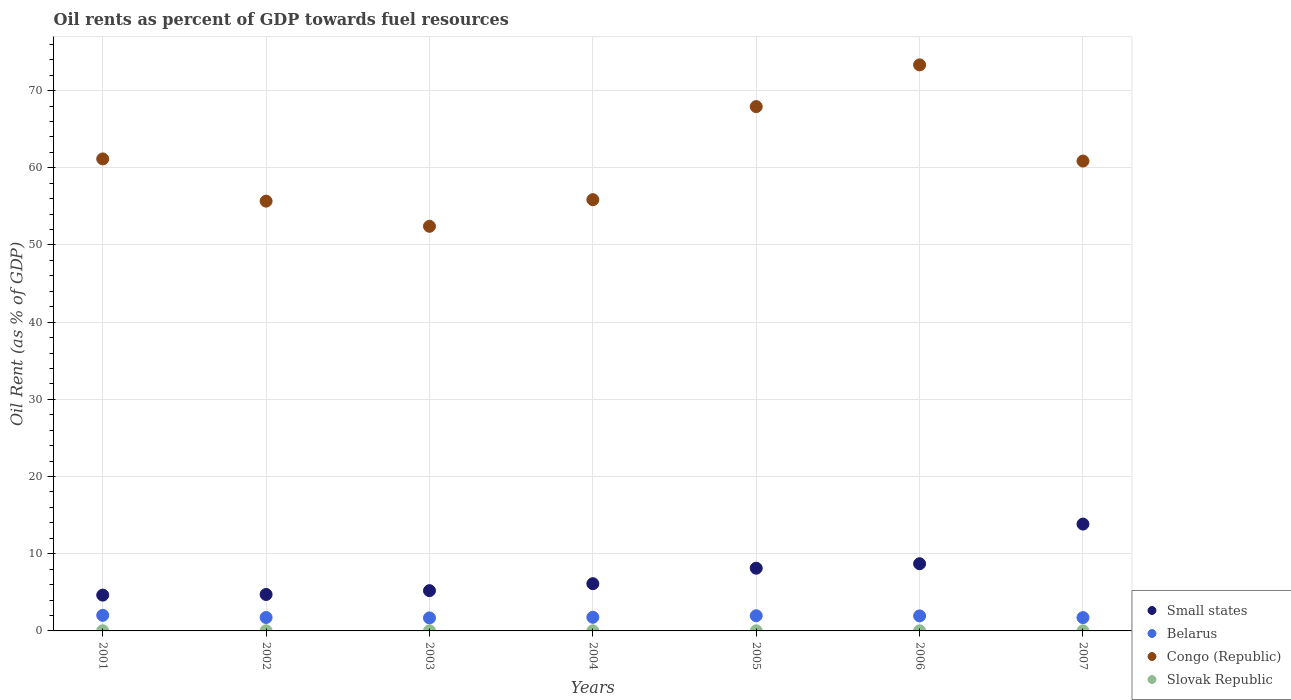How many different coloured dotlines are there?
Offer a very short reply. 4. Is the number of dotlines equal to the number of legend labels?
Make the answer very short. Yes. What is the oil rent in Congo (Republic) in 2001?
Make the answer very short. 61.15. Across all years, what is the maximum oil rent in Congo (Republic)?
Give a very brief answer. 73.33. Across all years, what is the minimum oil rent in Belarus?
Ensure brevity in your answer.  1.69. In which year was the oil rent in Belarus maximum?
Make the answer very short. 2001. In which year was the oil rent in Belarus minimum?
Offer a very short reply. 2003. What is the total oil rent in Congo (Republic) in the graph?
Make the answer very short. 427.25. What is the difference between the oil rent in Slovak Republic in 2005 and that in 2006?
Your response must be concise. 0. What is the difference between the oil rent in Small states in 2003 and the oil rent in Belarus in 2005?
Your answer should be compact. 3.25. What is the average oil rent in Belarus per year?
Provide a succinct answer. 1.84. In the year 2001, what is the difference between the oil rent in Congo (Republic) and oil rent in Belarus?
Ensure brevity in your answer.  59.13. What is the ratio of the oil rent in Congo (Republic) in 2003 to that in 2007?
Keep it short and to the point. 0.86. What is the difference between the highest and the second highest oil rent in Slovak Republic?
Give a very brief answer. 0. What is the difference between the highest and the lowest oil rent in Small states?
Your response must be concise. 9.2. Is the oil rent in Slovak Republic strictly greater than the oil rent in Belarus over the years?
Offer a very short reply. No. Is the oil rent in Congo (Republic) strictly less than the oil rent in Belarus over the years?
Offer a terse response. No. Does the graph contain any zero values?
Provide a short and direct response. No. Does the graph contain grids?
Offer a very short reply. Yes. Where does the legend appear in the graph?
Provide a succinct answer. Bottom right. What is the title of the graph?
Provide a short and direct response. Oil rents as percent of GDP towards fuel resources. Does "Channel Islands" appear as one of the legend labels in the graph?
Give a very brief answer. No. What is the label or title of the Y-axis?
Your answer should be very brief. Oil Rent (as % of GDP). What is the Oil Rent (as % of GDP) of Small states in 2001?
Your response must be concise. 4.64. What is the Oil Rent (as % of GDP) of Belarus in 2001?
Offer a very short reply. 2.02. What is the Oil Rent (as % of GDP) in Congo (Republic) in 2001?
Provide a short and direct response. 61.15. What is the Oil Rent (as % of GDP) in Slovak Republic in 2001?
Offer a terse response. 0.02. What is the Oil Rent (as % of GDP) in Small states in 2002?
Offer a terse response. 4.72. What is the Oil Rent (as % of GDP) of Belarus in 2002?
Give a very brief answer. 1.74. What is the Oil Rent (as % of GDP) of Congo (Republic) in 2002?
Your answer should be compact. 55.68. What is the Oil Rent (as % of GDP) in Slovak Republic in 2002?
Keep it short and to the point. 0.02. What is the Oil Rent (as % of GDP) in Small states in 2003?
Give a very brief answer. 5.22. What is the Oil Rent (as % of GDP) of Belarus in 2003?
Offer a terse response. 1.69. What is the Oil Rent (as % of GDP) in Congo (Republic) in 2003?
Give a very brief answer. 52.42. What is the Oil Rent (as % of GDP) in Slovak Republic in 2003?
Your answer should be compact. 0.01. What is the Oil Rent (as % of GDP) in Small states in 2004?
Provide a short and direct response. 6.12. What is the Oil Rent (as % of GDP) of Belarus in 2004?
Offer a terse response. 1.77. What is the Oil Rent (as % of GDP) in Congo (Republic) in 2004?
Offer a very short reply. 55.87. What is the Oil Rent (as % of GDP) of Slovak Republic in 2004?
Your answer should be compact. 0.02. What is the Oil Rent (as % of GDP) in Small states in 2005?
Give a very brief answer. 8.13. What is the Oil Rent (as % of GDP) of Belarus in 2005?
Ensure brevity in your answer.  1.97. What is the Oil Rent (as % of GDP) of Congo (Republic) in 2005?
Give a very brief answer. 67.93. What is the Oil Rent (as % of GDP) in Slovak Republic in 2005?
Offer a very short reply. 0.02. What is the Oil Rent (as % of GDP) in Small states in 2006?
Provide a succinct answer. 8.7. What is the Oil Rent (as % of GDP) of Belarus in 2006?
Your answer should be compact. 1.94. What is the Oil Rent (as % of GDP) in Congo (Republic) in 2006?
Offer a very short reply. 73.33. What is the Oil Rent (as % of GDP) of Slovak Republic in 2006?
Keep it short and to the point. 0.02. What is the Oil Rent (as % of GDP) in Small states in 2007?
Your answer should be compact. 13.84. What is the Oil Rent (as % of GDP) in Belarus in 2007?
Make the answer very short. 1.73. What is the Oil Rent (as % of GDP) in Congo (Republic) in 2007?
Make the answer very short. 60.87. What is the Oil Rent (as % of GDP) of Slovak Republic in 2007?
Your response must be concise. 0.01. Across all years, what is the maximum Oil Rent (as % of GDP) of Small states?
Keep it short and to the point. 13.84. Across all years, what is the maximum Oil Rent (as % of GDP) of Belarus?
Give a very brief answer. 2.02. Across all years, what is the maximum Oil Rent (as % of GDP) of Congo (Republic)?
Your answer should be compact. 73.33. Across all years, what is the maximum Oil Rent (as % of GDP) of Slovak Republic?
Offer a very short reply. 0.02. Across all years, what is the minimum Oil Rent (as % of GDP) in Small states?
Your answer should be compact. 4.64. Across all years, what is the minimum Oil Rent (as % of GDP) in Belarus?
Give a very brief answer. 1.69. Across all years, what is the minimum Oil Rent (as % of GDP) of Congo (Republic)?
Provide a short and direct response. 52.42. Across all years, what is the minimum Oil Rent (as % of GDP) in Slovak Republic?
Ensure brevity in your answer.  0.01. What is the total Oil Rent (as % of GDP) of Small states in the graph?
Provide a succinct answer. 51.37. What is the total Oil Rent (as % of GDP) of Belarus in the graph?
Provide a short and direct response. 12.85. What is the total Oil Rent (as % of GDP) in Congo (Republic) in the graph?
Ensure brevity in your answer.  427.25. What is the total Oil Rent (as % of GDP) in Slovak Republic in the graph?
Give a very brief answer. 0.11. What is the difference between the Oil Rent (as % of GDP) of Small states in 2001 and that in 2002?
Make the answer very short. -0.08. What is the difference between the Oil Rent (as % of GDP) in Belarus in 2001 and that in 2002?
Offer a very short reply. 0.28. What is the difference between the Oil Rent (as % of GDP) of Congo (Republic) in 2001 and that in 2002?
Your answer should be compact. 5.47. What is the difference between the Oil Rent (as % of GDP) in Slovak Republic in 2001 and that in 2002?
Make the answer very short. 0. What is the difference between the Oil Rent (as % of GDP) in Small states in 2001 and that in 2003?
Provide a short and direct response. -0.58. What is the difference between the Oil Rent (as % of GDP) in Belarus in 2001 and that in 2003?
Your answer should be compact. 0.34. What is the difference between the Oil Rent (as % of GDP) of Congo (Republic) in 2001 and that in 2003?
Offer a terse response. 8.73. What is the difference between the Oil Rent (as % of GDP) of Slovak Republic in 2001 and that in 2003?
Your response must be concise. 0.01. What is the difference between the Oil Rent (as % of GDP) of Small states in 2001 and that in 2004?
Offer a very short reply. -1.48. What is the difference between the Oil Rent (as % of GDP) in Belarus in 2001 and that in 2004?
Provide a succinct answer. 0.26. What is the difference between the Oil Rent (as % of GDP) in Congo (Republic) in 2001 and that in 2004?
Offer a very short reply. 5.28. What is the difference between the Oil Rent (as % of GDP) of Slovak Republic in 2001 and that in 2004?
Your answer should be compact. 0.01. What is the difference between the Oil Rent (as % of GDP) of Small states in 2001 and that in 2005?
Provide a succinct answer. -3.49. What is the difference between the Oil Rent (as % of GDP) in Belarus in 2001 and that in 2005?
Keep it short and to the point. 0.05. What is the difference between the Oil Rent (as % of GDP) of Congo (Republic) in 2001 and that in 2005?
Ensure brevity in your answer.  -6.78. What is the difference between the Oil Rent (as % of GDP) of Slovak Republic in 2001 and that in 2005?
Your answer should be very brief. 0. What is the difference between the Oil Rent (as % of GDP) of Small states in 2001 and that in 2006?
Make the answer very short. -4.07. What is the difference between the Oil Rent (as % of GDP) of Belarus in 2001 and that in 2006?
Ensure brevity in your answer.  0.08. What is the difference between the Oil Rent (as % of GDP) of Congo (Republic) in 2001 and that in 2006?
Provide a succinct answer. -12.18. What is the difference between the Oil Rent (as % of GDP) in Slovak Republic in 2001 and that in 2006?
Provide a succinct answer. 0. What is the difference between the Oil Rent (as % of GDP) of Small states in 2001 and that in 2007?
Keep it short and to the point. -9.2. What is the difference between the Oil Rent (as % of GDP) of Belarus in 2001 and that in 2007?
Offer a terse response. 0.3. What is the difference between the Oil Rent (as % of GDP) of Congo (Republic) in 2001 and that in 2007?
Offer a terse response. 0.28. What is the difference between the Oil Rent (as % of GDP) of Slovak Republic in 2001 and that in 2007?
Offer a very short reply. 0.01. What is the difference between the Oil Rent (as % of GDP) of Small states in 2002 and that in 2003?
Your response must be concise. -0.5. What is the difference between the Oil Rent (as % of GDP) of Belarus in 2002 and that in 2003?
Keep it short and to the point. 0.05. What is the difference between the Oil Rent (as % of GDP) in Congo (Republic) in 2002 and that in 2003?
Provide a short and direct response. 3.26. What is the difference between the Oil Rent (as % of GDP) in Slovak Republic in 2002 and that in 2003?
Ensure brevity in your answer.  0. What is the difference between the Oil Rent (as % of GDP) of Small states in 2002 and that in 2004?
Your response must be concise. -1.4. What is the difference between the Oil Rent (as % of GDP) of Belarus in 2002 and that in 2004?
Provide a short and direct response. -0.03. What is the difference between the Oil Rent (as % of GDP) in Congo (Republic) in 2002 and that in 2004?
Offer a very short reply. -0.19. What is the difference between the Oil Rent (as % of GDP) of Slovak Republic in 2002 and that in 2004?
Keep it short and to the point. 0. What is the difference between the Oil Rent (as % of GDP) of Small states in 2002 and that in 2005?
Provide a short and direct response. -3.4. What is the difference between the Oil Rent (as % of GDP) in Belarus in 2002 and that in 2005?
Give a very brief answer. -0.23. What is the difference between the Oil Rent (as % of GDP) of Congo (Republic) in 2002 and that in 2005?
Your answer should be very brief. -12.25. What is the difference between the Oil Rent (as % of GDP) of Slovak Republic in 2002 and that in 2005?
Give a very brief answer. 0. What is the difference between the Oil Rent (as % of GDP) in Small states in 2002 and that in 2006?
Provide a succinct answer. -3.98. What is the difference between the Oil Rent (as % of GDP) of Belarus in 2002 and that in 2006?
Provide a succinct answer. -0.21. What is the difference between the Oil Rent (as % of GDP) in Congo (Republic) in 2002 and that in 2006?
Your answer should be very brief. -17.65. What is the difference between the Oil Rent (as % of GDP) in Slovak Republic in 2002 and that in 2006?
Offer a terse response. 0. What is the difference between the Oil Rent (as % of GDP) of Small states in 2002 and that in 2007?
Give a very brief answer. -9.12. What is the difference between the Oil Rent (as % of GDP) of Belarus in 2002 and that in 2007?
Give a very brief answer. 0.01. What is the difference between the Oil Rent (as % of GDP) in Congo (Republic) in 2002 and that in 2007?
Make the answer very short. -5.19. What is the difference between the Oil Rent (as % of GDP) in Slovak Republic in 2002 and that in 2007?
Make the answer very short. 0.01. What is the difference between the Oil Rent (as % of GDP) of Small states in 2003 and that in 2004?
Give a very brief answer. -0.9. What is the difference between the Oil Rent (as % of GDP) of Belarus in 2003 and that in 2004?
Provide a succinct answer. -0.08. What is the difference between the Oil Rent (as % of GDP) in Congo (Republic) in 2003 and that in 2004?
Offer a very short reply. -3.45. What is the difference between the Oil Rent (as % of GDP) in Slovak Republic in 2003 and that in 2004?
Make the answer very short. -0. What is the difference between the Oil Rent (as % of GDP) in Small states in 2003 and that in 2005?
Make the answer very short. -2.91. What is the difference between the Oil Rent (as % of GDP) in Belarus in 2003 and that in 2005?
Your answer should be very brief. -0.28. What is the difference between the Oil Rent (as % of GDP) of Congo (Republic) in 2003 and that in 2005?
Provide a succinct answer. -15.51. What is the difference between the Oil Rent (as % of GDP) of Slovak Republic in 2003 and that in 2005?
Offer a very short reply. -0. What is the difference between the Oil Rent (as % of GDP) in Small states in 2003 and that in 2006?
Your response must be concise. -3.49. What is the difference between the Oil Rent (as % of GDP) in Belarus in 2003 and that in 2006?
Your answer should be compact. -0.26. What is the difference between the Oil Rent (as % of GDP) of Congo (Republic) in 2003 and that in 2006?
Provide a succinct answer. -20.91. What is the difference between the Oil Rent (as % of GDP) in Slovak Republic in 2003 and that in 2006?
Your answer should be very brief. -0. What is the difference between the Oil Rent (as % of GDP) in Small states in 2003 and that in 2007?
Your answer should be compact. -8.63. What is the difference between the Oil Rent (as % of GDP) in Belarus in 2003 and that in 2007?
Ensure brevity in your answer.  -0.04. What is the difference between the Oil Rent (as % of GDP) of Congo (Republic) in 2003 and that in 2007?
Ensure brevity in your answer.  -8.45. What is the difference between the Oil Rent (as % of GDP) of Slovak Republic in 2003 and that in 2007?
Ensure brevity in your answer.  0. What is the difference between the Oil Rent (as % of GDP) of Small states in 2004 and that in 2005?
Your answer should be compact. -2.01. What is the difference between the Oil Rent (as % of GDP) in Belarus in 2004 and that in 2005?
Offer a terse response. -0.2. What is the difference between the Oil Rent (as % of GDP) of Congo (Republic) in 2004 and that in 2005?
Keep it short and to the point. -12.06. What is the difference between the Oil Rent (as % of GDP) of Slovak Republic in 2004 and that in 2005?
Provide a short and direct response. -0. What is the difference between the Oil Rent (as % of GDP) in Small states in 2004 and that in 2006?
Provide a short and direct response. -2.58. What is the difference between the Oil Rent (as % of GDP) of Belarus in 2004 and that in 2006?
Make the answer very short. -0.18. What is the difference between the Oil Rent (as % of GDP) in Congo (Republic) in 2004 and that in 2006?
Offer a terse response. -17.46. What is the difference between the Oil Rent (as % of GDP) in Slovak Republic in 2004 and that in 2006?
Provide a succinct answer. -0. What is the difference between the Oil Rent (as % of GDP) in Small states in 2004 and that in 2007?
Your answer should be compact. -7.72. What is the difference between the Oil Rent (as % of GDP) of Belarus in 2004 and that in 2007?
Provide a short and direct response. 0.04. What is the difference between the Oil Rent (as % of GDP) in Congo (Republic) in 2004 and that in 2007?
Provide a succinct answer. -5. What is the difference between the Oil Rent (as % of GDP) of Slovak Republic in 2004 and that in 2007?
Provide a succinct answer. 0. What is the difference between the Oil Rent (as % of GDP) in Small states in 2005 and that in 2006?
Your answer should be very brief. -0.58. What is the difference between the Oil Rent (as % of GDP) in Belarus in 2005 and that in 2006?
Give a very brief answer. 0.02. What is the difference between the Oil Rent (as % of GDP) in Congo (Republic) in 2005 and that in 2006?
Offer a very short reply. -5.41. What is the difference between the Oil Rent (as % of GDP) of Small states in 2005 and that in 2007?
Your answer should be very brief. -5.72. What is the difference between the Oil Rent (as % of GDP) in Belarus in 2005 and that in 2007?
Ensure brevity in your answer.  0.24. What is the difference between the Oil Rent (as % of GDP) of Congo (Republic) in 2005 and that in 2007?
Provide a short and direct response. 7.05. What is the difference between the Oil Rent (as % of GDP) in Slovak Republic in 2005 and that in 2007?
Your response must be concise. 0.01. What is the difference between the Oil Rent (as % of GDP) of Small states in 2006 and that in 2007?
Offer a terse response. -5.14. What is the difference between the Oil Rent (as % of GDP) of Belarus in 2006 and that in 2007?
Your answer should be very brief. 0.22. What is the difference between the Oil Rent (as % of GDP) in Congo (Republic) in 2006 and that in 2007?
Ensure brevity in your answer.  12.46. What is the difference between the Oil Rent (as % of GDP) in Slovak Republic in 2006 and that in 2007?
Your answer should be compact. 0. What is the difference between the Oil Rent (as % of GDP) in Small states in 2001 and the Oil Rent (as % of GDP) in Belarus in 2002?
Provide a succinct answer. 2.9. What is the difference between the Oil Rent (as % of GDP) of Small states in 2001 and the Oil Rent (as % of GDP) of Congo (Republic) in 2002?
Provide a succinct answer. -51.04. What is the difference between the Oil Rent (as % of GDP) of Small states in 2001 and the Oil Rent (as % of GDP) of Slovak Republic in 2002?
Offer a very short reply. 4.62. What is the difference between the Oil Rent (as % of GDP) of Belarus in 2001 and the Oil Rent (as % of GDP) of Congo (Republic) in 2002?
Your response must be concise. -53.66. What is the difference between the Oil Rent (as % of GDP) in Belarus in 2001 and the Oil Rent (as % of GDP) in Slovak Republic in 2002?
Provide a succinct answer. 2. What is the difference between the Oil Rent (as % of GDP) of Congo (Republic) in 2001 and the Oil Rent (as % of GDP) of Slovak Republic in 2002?
Offer a very short reply. 61.13. What is the difference between the Oil Rent (as % of GDP) in Small states in 2001 and the Oil Rent (as % of GDP) in Belarus in 2003?
Ensure brevity in your answer.  2.95. What is the difference between the Oil Rent (as % of GDP) in Small states in 2001 and the Oil Rent (as % of GDP) in Congo (Republic) in 2003?
Make the answer very short. -47.78. What is the difference between the Oil Rent (as % of GDP) in Small states in 2001 and the Oil Rent (as % of GDP) in Slovak Republic in 2003?
Ensure brevity in your answer.  4.62. What is the difference between the Oil Rent (as % of GDP) in Belarus in 2001 and the Oil Rent (as % of GDP) in Congo (Republic) in 2003?
Your answer should be compact. -50.4. What is the difference between the Oil Rent (as % of GDP) in Belarus in 2001 and the Oil Rent (as % of GDP) in Slovak Republic in 2003?
Keep it short and to the point. 2.01. What is the difference between the Oil Rent (as % of GDP) of Congo (Republic) in 2001 and the Oil Rent (as % of GDP) of Slovak Republic in 2003?
Your answer should be very brief. 61.13. What is the difference between the Oil Rent (as % of GDP) of Small states in 2001 and the Oil Rent (as % of GDP) of Belarus in 2004?
Offer a terse response. 2.87. What is the difference between the Oil Rent (as % of GDP) of Small states in 2001 and the Oil Rent (as % of GDP) of Congo (Republic) in 2004?
Provide a short and direct response. -51.23. What is the difference between the Oil Rent (as % of GDP) in Small states in 2001 and the Oil Rent (as % of GDP) in Slovak Republic in 2004?
Your answer should be compact. 4.62. What is the difference between the Oil Rent (as % of GDP) of Belarus in 2001 and the Oil Rent (as % of GDP) of Congo (Republic) in 2004?
Keep it short and to the point. -53.85. What is the difference between the Oil Rent (as % of GDP) of Belarus in 2001 and the Oil Rent (as % of GDP) of Slovak Republic in 2004?
Provide a succinct answer. 2.01. What is the difference between the Oil Rent (as % of GDP) of Congo (Republic) in 2001 and the Oil Rent (as % of GDP) of Slovak Republic in 2004?
Offer a terse response. 61.13. What is the difference between the Oil Rent (as % of GDP) in Small states in 2001 and the Oil Rent (as % of GDP) in Belarus in 2005?
Your answer should be compact. 2.67. What is the difference between the Oil Rent (as % of GDP) of Small states in 2001 and the Oil Rent (as % of GDP) of Congo (Republic) in 2005?
Offer a very short reply. -63.29. What is the difference between the Oil Rent (as % of GDP) in Small states in 2001 and the Oil Rent (as % of GDP) in Slovak Republic in 2005?
Give a very brief answer. 4.62. What is the difference between the Oil Rent (as % of GDP) in Belarus in 2001 and the Oil Rent (as % of GDP) in Congo (Republic) in 2005?
Provide a short and direct response. -65.9. What is the difference between the Oil Rent (as % of GDP) of Belarus in 2001 and the Oil Rent (as % of GDP) of Slovak Republic in 2005?
Make the answer very short. 2. What is the difference between the Oil Rent (as % of GDP) in Congo (Republic) in 2001 and the Oil Rent (as % of GDP) in Slovak Republic in 2005?
Your answer should be very brief. 61.13. What is the difference between the Oil Rent (as % of GDP) of Small states in 2001 and the Oil Rent (as % of GDP) of Belarus in 2006?
Offer a terse response. 2.69. What is the difference between the Oil Rent (as % of GDP) of Small states in 2001 and the Oil Rent (as % of GDP) of Congo (Republic) in 2006?
Your answer should be very brief. -68.69. What is the difference between the Oil Rent (as % of GDP) in Small states in 2001 and the Oil Rent (as % of GDP) in Slovak Republic in 2006?
Your answer should be compact. 4.62. What is the difference between the Oil Rent (as % of GDP) of Belarus in 2001 and the Oil Rent (as % of GDP) of Congo (Republic) in 2006?
Give a very brief answer. -71.31. What is the difference between the Oil Rent (as % of GDP) of Belarus in 2001 and the Oil Rent (as % of GDP) of Slovak Republic in 2006?
Provide a short and direct response. 2.01. What is the difference between the Oil Rent (as % of GDP) in Congo (Republic) in 2001 and the Oil Rent (as % of GDP) in Slovak Republic in 2006?
Your answer should be very brief. 61.13. What is the difference between the Oil Rent (as % of GDP) of Small states in 2001 and the Oil Rent (as % of GDP) of Belarus in 2007?
Keep it short and to the point. 2.91. What is the difference between the Oil Rent (as % of GDP) of Small states in 2001 and the Oil Rent (as % of GDP) of Congo (Republic) in 2007?
Ensure brevity in your answer.  -56.23. What is the difference between the Oil Rent (as % of GDP) in Small states in 2001 and the Oil Rent (as % of GDP) in Slovak Republic in 2007?
Offer a very short reply. 4.63. What is the difference between the Oil Rent (as % of GDP) in Belarus in 2001 and the Oil Rent (as % of GDP) in Congo (Republic) in 2007?
Your answer should be very brief. -58.85. What is the difference between the Oil Rent (as % of GDP) of Belarus in 2001 and the Oil Rent (as % of GDP) of Slovak Republic in 2007?
Keep it short and to the point. 2.01. What is the difference between the Oil Rent (as % of GDP) of Congo (Republic) in 2001 and the Oil Rent (as % of GDP) of Slovak Republic in 2007?
Keep it short and to the point. 61.14. What is the difference between the Oil Rent (as % of GDP) in Small states in 2002 and the Oil Rent (as % of GDP) in Belarus in 2003?
Offer a very short reply. 3.04. What is the difference between the Oil Rent (as % of GDP) of Small states in 2002 and the Oil Rent (as % of GDP) of Congo (Republic) in 2003?
Offer a terse response. -47.7. What is the difference between the Oil Rent (as % of GDP) of Small states in 2002 and the Oil Rent (as % of GDP) of Slovak Republic in 2003?
Provide a succinct answer. 4.71. What is the difference between the Oil Rent (as % of GDP) in Belarus in 2002 and the Oil Rent (as % of GDP) in Congo (Republic) in 2003?
Provide a short and direct response. -50.68. What is the difference between the Oil Rent (as % of GDP) in Belarus in 2002 and the Oil Rent (as % of GDP) in Slovak Republic in 2003?
Your answer should be very brief. 1.72. What is the difference between the Oil Rent (as % of GDP) in Congo (Republic) in 2002 and the Oil Rent (as % of GDP) in Slovak Republic in 2003?
Offer a very short reply. 55.67. What is the difference between the Oil Rent (as % of GDP) in Small states in 2002 and the Oil Rent (as % of GDP) in Belarus in 2004?
Keep it short and to the point. 2.96. What is the difference between the Oil Rent (as % of GDP) in Small states in 2002 and the Oil Rent (as % of GDP) in Congo (Republic) in 2004?
Make the answer very short. -51.15. What is the difference between the Oil Rent (as % of GDP) in Small states in 2002 and the Oil Rent (as % of GDP) in Slovak Republic in 2004?
Make the answer very short. 4.71. What is the difference between the Oil Rent (as % of GDP) of Belarus in 2002 and the Oil Rent (as % of GDP) of Congo (Republic) in 2004?
Offer a terse response. -54.13. What is the difference between the Oil Rent (as % of GDP) of Belarus in 2002 and the Oil Rent (as % of GDP) of Slovak Republic in 2004?
Ensure brevity in your answer.  1.72. What is the difference between the Oil Rent (as % of GDP) in Congo (Republic) in 2002 and the Oil Rent (as % of GDP) in Slovak Republic in 2004?
Offer a terse response. 55.67. What is the difference between the Oil Rent (as % of GDP) of Small states in 2002 and the Oil Rent (as % of GDP) of Belarus in 2005?
Your answer should be compact. 2.75. What is the difference between the Oil Rent (as % of GDP) in Small states in 2002 and the Oil Rent (as % of GDP) in Congo (Republic) in 2005?
Give a very brief answer. -63.2. What is the difference between the Oil Rent (as % of GDP) in Small states in 2002 and the Oil Rent (as % of GDP) in Slovak Republic in 2005?
Provide a short and direct response. 4.7. What is the difference between the Oil Rent (as % of GDP) of Belarus in 2002 and the Oil Rent (as % of GDP) of Congo (Republic) in 2005?
Give a very brief answer. -66.19. What is the difference between the Oil Rent (as % of GDP) of Belarus in 2002 and the Oil Rent (as % of GDP) of Slovak Republic in 2005?
Give a very brief answer. 1.72. What is the difference between the Oil Rent (as % of GDP) in Congo (Republic) in 2002 and the Oil Rent (as % of GDP) in Slovak Republic in 2005?
Offer a terse response. 55.66. What is the difference between the Oil Rent (as % of GDP) in Small states in 2002 and the Oil Rent (as % of GDP) in Belarus in 2006?
Ensure brevity in your answer.  2.78. What is the difference between the Oil Rent (as % of GDP) of Small states in 2002 and the Oil Rent (as % of GDP) of Congo (Republic) in 2006?
Provide a short and direct response. -68.61. What is the difference between the Oil Rent (as % of GDP) of Small states in 2002 and the Oil Rent (as % of GDP) of Slovak Republic in 2006?
Your answer should be very brief. 4.71. What is the difference between the Oil Rent (as % of GDP) of Belarus in 2002 and the Oil Rent (as % of GDP) of Congo (Republic) in 2006?
Your response must be concise. -71.59. What is the difference between the Oil Rent (as % of GDP) of Belarus in 2002 and the Oil Rent (as % of GDP) of Slovak Republic in 2006?
Give a very brief answer. 1.72. What is the difference between the Oil Rent (as % of GDP) in Congo (Republic) in 2002 and the Oil Rent (as % of GDP) in Slovak Republic in 2006?
Make the answer very short. 55.66. What is the difference between the Oil Rent (as % of GDP) of Small states in 2002 and the Oil Rent (as % of GDP) of Belarus in 2007?
Keep it short and to the point. 3. What is the difference between the Oil Rent (as % of GDP) in Small states in 2002 and the Oil Rent (as % of GDP) in Congo (Republic) in 2007?
Offer a terse response. -56.15. What is the difference between the Oil Rent (as % of GDP) of Small states in 2002 and the Oil Rent (as % of GDP) of Slovak Republic in 2007?
Keep it short and to the point. 4.71. What is the difference between the Oil Rent (as % of GDP) in Belarus in 2002 and the Oil Rent (as % of GDP) in Congo (Republic) in 2007?
Ensure brevity in your answer.  -59.13. What is the difference between the Oil Rent (as % of GDP) in Belarus in 2002 and the Oil Rent (as % of GDP) in Slovak Republic in 2007?
Ensure brevity in your answer.  1.73. What is the difference between the Oil Rent (as % of GDP) in Congo (Republic) in 2002 and the Oil Rent (as % of GDP) in Slovak Republic in 2007?
Provide a succinct answer. 55.67. What is the difference between the Oil Rent (as % of GDP) of Small states in 2003 and the Oil Rent (as % of GDP) of Belarus in 2004?
Ensure brevity in your answer.  3.45. What is the difference between the Oil Rent (as % of GDP) of Small states in 2003 and the Oil Rent (as % of GDP) of Congo (Republic) in 2004?
Make the answer very short. -50.65. What is the difference between the Oil Rent (as % of GDP) in Small states in 2003 and the Oil Rent (as % of GDP) in Slovak Republic in 2004?
Your answer should be compact. 5.2. What is the difference between the Oil Rent (as % of GDP) in Belarus in 2003 and the Oil Rent (as % of GDP) in Congo (Republic) in 2004?
Give a very brief answer. -54.18. What is the difference between the Oil Rent (as % of GDP) in Belarus in 2003 and the Oil Rent (as % of GDP) in Slovak Republic in 2004?
Provide a succinct answer. 1.67. What is the difference between the Oil Rent (as % of GDP) in Congo (Republic) in 2003 and the Oil Rent (as % of GDP) in Slovak Republic in 2004?
Keep it short and to the point. 52.41. What is the difference between the Oil Rent (as % of GDP) of Small states in 2003 and the Oil Rent (as % of GDP) of Belarus in 2005?
Give a very brief answer. 3.25. What is the difference between the Oil Rent (as % of GDP) of Small states in 2003 and the Oil Rent (as % of GDP) of Congo (Republic) in 2005?
Provide a short and direct response. -62.71. What is the difference between the Oil Rent (as % of GDP) of Small states in 2003 and the Oil Rent (as % of GDP) of Slovak Republic in 2005?
Provide a succinct answer. 5.2. What is the difference between the Oil Rent (as % of GDP) in Belarus in 2003 and the Oil Rent (as % of GDP) in Congo (Republic) in 2005?
Give a very brief answer. -66.24. What is the difference between the Oil Rent (as % of GDP) of Belarus in 2003 and the Oil Rent (as % of GDP) of Slovak Republic in 2005?
Your answer should be compact. 1.67. What is the difference between the Oil Rent (as % of GDP) of Congo (Republic) in 2003 and the Oil Rent (as % of GDP) of Slovak Republic in 2005?
Your response must be concise. 52.4. What is the difference between the Oil Rent (as % of GDP) of Small states in 2003 and the Oil Rent (as % of GDP) of Belarus in 2006?
Provide a short and direct response. 3.27. What is the difference between the Oil Rent (as % of GDP) in Small states in 2003 and the Oil Rent (as % of GDP) in Congo (Republic) in 2006?
Provide a succinct answer. -68.12. What is the difference between the Oil Rent (as % of GDP) in Small states in 2003 and the Oil Rent (as % of GDP) in Slovak Republic in 2006?
Offer a very short reply. 5.2. What is the difference between the Oil Rent (as % of GDP) of Belarus in 2003 and the Oil Rent (as % of GDP) of Congo (Republic) in 2006?
Provide a succinct answer. -71.65. What is the difference between the Oil Rent (as % of GDP) of Belarus in 2003 and the Oil Rent (as % of GDP) of Slovak Republic in 2006?
Keep it short and to the point. 1.67. What is the difference between the Oil Rent (as % of GDP) in Congo (Republic) in 2003 and the Oil Rent (as % of GDP) in Slovak Republic in 2006?
Make the answer very short. 52.4. What is the difference between the Oil Rent (as % of GDP) in Small states in 2003 and the Oil Rent (as % of GDP) in Belarus in 2007?
Your response must be concise. 3.49. What is the difference between the Oil Rent (as % of GDP) of Small states in 2003 and the Oil Rent (as % of GDP) of Congo (Republic) in 2007?
Your answer should be very brief. -55.66. What is the difference between the Oil Rent (as % of GDP) of Small states in 2003 and the Oil Rent (as % of GDP) of Slovak Republic in 2007?
Offer a terse response. 5.21. What is the difference between the Oil Rent (as % of GDP) of Belarus in 2003 and the Oil Rent (as % of GDP) of Congo (Republic) in 2007?
Offer a terse response. -59.19. What is the difference between the Oil Rent (as % of GDP) of Belarus in 2003 and the Oil Rent (as % of GDP) of Slovak Republic in 2007?
Provide a succinct answer. 1.67. What is the difference between the Oil Rent (as % of GDP) of Congo (Republic) in 2003 and the Oil Rent (as % of GDP) of Slovak Republic in 2007?
Make the answer very short. 52.41. What is the difference between the Oil Rent (as % of GDP) of Small states in 2004 and the Oil Rent (as % of GDP) of Belarus in 2005?
Keep it short and to the point. 4.15. What is the difference between the Oil Rent (as % of GDP) of Small states in 2004 and the Oil Rent (as % of GDP) of Congo (Republic) in 2005?
Provide a short and direct response. -61.81. What is the difference between the Oil Rent (as % of GDP) in Small states in 2004 and the Oil Rent (as % of GDP) in Slovak Republic in 2005?
Your answer should be very brief. 6.1. What is the difference between the Oil Rent (as % of GDP) in Belarus in 2004 and the Oil Rent (as % of GDP) in Congo (Republic) in 2005?
Offer a very short reply. -66.16. What is the difference between the Oil Rent (as % of GDP) of Belarus in 2004 and the Oil Rent (as % of GDP) of Slovak Republic in 2005?
Give a very brief answer. 1.75. What is the difference between the Oil Rent (as % of GDP) of Congo (Republic) in 2004 and the Oil Rent (as % of GDP) of Slovak Republic in 2005?
Your response must be concise. 55.85. What is the difference between the Oil Rent (as % of GDP) in Small states in 2004 and the Oil Rent (as % of GDP) in Belarus in 2006?
Your response must be concise. 4.17. What is the difference between the Oil Rent (as % of GDP) in Small states in 2004 and the Oil Rent (as % of GDP) in Congo (Republic) in 2006?
Keep it short and to the point. -67.21. What is the difference between the Oil Rent (as % of GDP) of Small states in 2004 and the Oil Rent (as % of GDP) of Slovak Republic in 2006?
Your response must be concise. 6.1. What is the difference between the Oil Rent (as % of GDP) of Belarus in 2004 and the Oil Rent (as % of GDP) of Congo (Republic) in 2006?
Provide a succinct answer. -71.57. What is the difference between the Oil Rent (as % of GDP) in Belarus in 2004 and the Oil Rent (as % of GDP) in Slovak Republic in 2006?
Make the answer very short. 1.75. What is the difference between the Oil Rent (as % of GDP) of Congo (Republic) in 2004 and the Oil Rent (as % of GDP) of Slovak Republic in 2006?
Keep it short and to the point. 55.85. What is the difference between the Oil Rent (as % of GDP) of Small states in 2004 and the Oil Rent (as % of GDP) of Belarus in 2007?
Keep it short and to the point. 4.39. What is the difference between the Oil Rent (as % of GDP) of Small states in 2004 and the Oil Rent (as % of GDP) of Congo (Republic) in 2007?
Your answer should be compact. -54.75. What is the difference between the Oil Rent (as % of GDP) in Small states in 2004 and the Oil Rent (as % of GDP) in Slovak Republic in 2007?
Provide a short and direct response. 6.11. What is the difference between the Oil Rent (as % of GDP) of Belarus in 2004 and the Oil Rent (as % of GDP) of Congo (Republic) in 2007?
Your answer should be compact. -59.11. What is the difference between the Oil Rent (as % of GDP) of Belarus in 2004 and the Oil Rent (as % of GDP) of Slovak Republic in 2007?
Offer a terse response. 1.75. What is the difference between the Oil Rent (as % of GDP) in Congo (Republic) in 2004 and the Oil Rent (as % of GDP) in Slovak Republic in 2007?
Offer a terse response. 55.86. What is the difference between the Oil Rent (as % of GDP) of Small states in 2005 and the Oil Rent (as % of GDP) of Belarus in 2006?
Keep it short and to the point. 6.18. What is the difference between the Oil Rent (as % of GDP) of Small states in 2005 and the Oil Rent (as % of GDP) of Congo (Republic) in 2006?
Your answer should be very brief. -65.21. What is the difference between the Oil Rent (as % of GDP) of Small states in 2005 and the Oil Rent (as % of GDP) of Slovak Republic in 2006?
Your response must be concise. 8.11. What is the difference between the Oil Rent (as % of GDP) of Belarus in 2005 and the Oil Rent (as % of GDP) of Congo (Republic) in 2006?
Make the answer very short. -71.36. What is the difference between the Oil Rent (as % of GDP) of Belarus in 2005 and the Oil Rent (as % of GDP) of Slovak Republic in 2006?
Your answer should be very brief. 1.95. What is the difference between the Oil Rent (as % of GDP) in Congo (Republic) in 2005 and the Oil Rent (as % of GDP) in Slovak Republic in 2006?
Offer a very short reply. 67.91. What is the difference between the Oil Rent (as % of GDP) of Small states in 2005 and the Oil Rent (as % of GDP) of Belarus in 2007?
Give a very brief answer. 6.4. What is the difference between the Oil Rent (as % of GDP) of Small states in 2005 and the Oil Rent (as % of GDP) of Congo (Republic) in 2007?
Provide a short and direct response. -52.75. What is the difference between the Oil Rent (as % of GDP) of Small states in 2005 and the Oil Rent (as % of GDP) of Slovak Republic in 2007?
Offer a very short reply. 8.11. What is the difference between the Oil Rent (as % of GDP) in Belarus in 2005 and the Oil Rent (as % of GDP) in Congo (Republic) in 2007?
Provide a succinct answer. -58.91. What is the difference between the Oil Rent (as % of GDP) in Belarus in 2005 and the Oil Rent (as % of GDP) in Slovak Republic in 2007?
Offer a very short reply. 1.96. What is the difference between the Oil Rent (as % of GDP) of Congo (Republic) in 2005 and the Oil Rent (as % of GDP) of Slovak Republic in 2007?
Ensure brevity in your answer.  67.91. What is the difference between the Oil Rent (as % of GDP) in Small states in 2006 and the Oil Rent (as % of GDP) in Belarus in 2007?
Provide a short and direct response. 6.98. What is the difference between the Oil Rent (as % of GDP) of Small states in 2006 and the Oil Rent (as % of GDP) of Congo (Republic) in 2007?
Keep it short and to the point. -52.17. What is the difference between the Oil Rent (as % of GDP) of Small states in 2006 and the Oil Rent (as % of GDP) of Slovak Republic in 2007?
Ensure brevity in your answer.  8.69. What is the difference between the Oil Rent (as % of GDP) of Belarus in 2006 and the Oil Rent (as % of GDP) of Congo (Republic) in 2007?
Provide a succinct answer. -58.93. What is the difference between the Oil Rent (as % of GDP) in Belarus in 2006 and the Oil Rent (as % of GDP) in Slovak Republic in 2007?
Give a very brief answer. 1.93. What is the difference between the Oil Rent (as % of GDP) in Congo (Republic) in 2006 and the Oil Rent (as % of GDP) in Slovak Republic in 2007?
Offer a very short reply. 73.32. What is the average Oil Rent (as % of GDP) of Small states per year?
Keep it short and to the point. 7.34. What is the average Oil Rent (as % of GDP) in Belarus per year?
Provide a short and direct response. 1.84. What is the average Oil Rent (as % of GDP) in Congo (Republic) per year?
Your answer should be compact. 61.04. What is the average Oil Rent (as % of GDP) in Slovak Republic per year?
Offer a terse response. 0.02. In the year 2001, what is the difference between the Oil Rent (as % of GDP) in Small states and Oil Rent (as % of GDP) in Belarus?
Offer a terse response. 2.62. In the year 2001, what is the difference between the Oil Rent (as % of GDP) of Small states and Oil Rent (as % of GDP) of Congo (Republic)?
Ensure brevity in your answer.  -56.51. In the year 2001, what is the difference between the Oil Rent (as % of GDP) in Small states and Oil Rent (as % of GDP) in Slovak Republic?
Give a very brief answer. 4.62. In the year 2001, what is the difference between the Oil Rent (as % of GDP) of Belarus and Oil Rent (as % of GDP) of Congo (Republic)?
Provide a short and direct response. -59.13. In the year 2001, what is the difference between the Oil Rent (as % of GDP) of Belarus and Oil Rent (as % of GDP) of Slovak Republic?
Your answer should be very brief. 2. In the year 2001, what is the difference between the Oil Rent (as % of GDP) of Congo (Republic) and Oil Rent (as % of GDP) of Slovak Republic?
Provide a succinct answer. 61.13. In the year 2002, what is the difference between the Oil Rent (as % of GDP) in Small states and Oil Rent (as % of GDP) in Belarus?
Offer a terse response. 2.98. In the year 2002, what is the difference between the Oil Rent (as % of GDP) in Small states and Oil Rent (as % of GDP) in Congo (Republic)?
Provide a short and direct response. -50.96. In the year 2002, what is the difference between the Oil Rent (as % of GDP) of Small states and Oil Rent (as % of GDP) of Slovak Republic?
Your answer should be compact. 4.7. In the year 2002, what is the difference between the Oil Rent (as % of GDP) in Belarus and Oil Rent (as % of GDP) in Congo (Republic)?
Your answer should be compact. -53.94. In the year 2002, what is the difference between the Oil Rent (as % of GDP) of Belarus and Oil Rent (as % of GDP) of Slovak Republic?
Ensure brevity in your answer.  1.72. In the year 2002, what is the difference between the Oil Rent (as % of GDP) of Congo (Republic) and Oil Rent (as % of GDP) of Slovak Republic?
Provide a succinct answer. 55.66. In the year 2003, what is the difference between the Oil Rent (as % of GDP) of Small states and Oil Rent (as % of GDP) of Belarus?
Offer a terse response. 3.53. In the year 2003, what is the difference between the Oil Rent (as % of GDP) in Small states and Oil Rent (as % of GDP) in Congo (Republic)?
Your response must be concise. -47.2. In the year 2003, what is the difference between the Oil Rent (as % of GDP) in Small states and Oil Rent (as % of GDP) in Slovak Republic?
Ensure brevity in your answer.  5.2. In the year 2003, what is the difference between the Oil Rent (as % of GDP) in Belarus and Oil Rent (as % of GDP) in Congo (Republic)?
Offer a terse response. -50.74. In the year 2003, what is the difference between the Oil Rent (as % of GDP) of Belarus and Oil Rent (as % of GDP) of Slovak Republic?
Provide a succinct answer. 1.67. In the year 2003, what is the difference between the Oil Rent (as % of GDP) of Congo (Republic) and Oil Rent (as % of GDP) of Slovak Republic?
Provide a succinct answer. 52.41. In the year 2004, what is the difference between the Oil Rent (as % of GDP) of Small states and Oil Rent (as % of GDP) of Belarus?
Offer a very short reply. 4.35. In the year 2004, what is the difference between the Oil Rent (as % of GDP) of Small states and Oil Rent (as % of GDP) of Congo (Republic)?
Ensure brevity in your answer.  -49.75. In the year 2004, what is the difference between the Oil Rent (as % of GDP) of Small states and Oil Rent (as % of GDP) of Slovak Republic?
Offer a terse response. 6.1. In the year 2004, what is the difference between the Oil Rent (as % of GDP) in Belarus and Oil Rent (as % of GDP) in Congo (Republic)?
Your answer should be compact. -54.1. In the year 2004, what is the difference between the Oil Rent (as % of GDP) in Belarus and Oil Rent (as % of GDP) in Slovak Republic?
Give a very brief answer. 1.75. In the year 2004, what is the difference between the Oil Rent (as % of GDP) of Congo (Republic) and Oil Rent (as % of GDP) of Slovak Republic?
Provide a succinct answer. 55.85. In the year 2005, what is the difference between the Oil Rent (as % of GDP) in Small states and Oil Rent (as % of GDP) in Belarus?
Provide a short and direct response. 6.16. In the year 2005, what is the difference between the Oil Rent (as % of GDP) in Small states and Oil Rent (as % of GDP) in Congo (Republic)?
Your answer should be compact. -59.8. In the year 2005, what is the difference between the Oil Rent (as % of GDP) of Small states and Oil Rent (as % of GDP) of Slovak Republic?
Provide a short and direct response. 8.11. In the year 2005, what is the difference between the Oil Rent (as % of GDP) in Belarus and Oil Rent (as % of GDP) in Congo (Republic)?
Provide a succinct answer. -65.96. In the year 2005, what is the difference between the Oil Rent (as % of GDP) in Belarus and Oil Rent (as % of GDP) in Slovak Republic?
Give a very brief answer. 1.95. In the year 2005, what is the difference between the Oil Rent (as % of GDP) of Congo (Republic) and Oil Rent (as % of GDP) of Slovak Republic?
Make the answer very short. 67.91. In the year 2006, what is the difference between the Oil Rent (as % of GDP) of Small states and Oil Rent (as % of GDP) of Belarus?
Your answer should be compact. 6.76. In the year 2006, what is the difference between the Oil Rent (as % of GDP) of Small states and Oil Rent (as % of GDP) of Congo (Republic)?
Your answer should be very brief. -64.63. In the year 2006, what is the difference between the Oil Rent (as % of GDP) in Small states and Oil Rent (as % of GDP) in Slovak Republic?
Provide a succinct answer. 8.69. In the year 2006, what is the difference between the Oil Rent (as % of GDP) in Belarus and Oil Rent (as % of GDP) in Congo (Republic)?
Your response must be concise. -71.39. In the year 2006, what is the difference between the Oil Rent (as % of GDP) in Belarus and Oil Rent (as % of GDP) in Slovak Republic?
Provide a succinct answer. 1.93. In the year 2006, what is the difference between the Oil Rent (as % of GDP) in Congo (Republic) and Oil Rent (as % of GDP) in Slovak Republic?
Give a very brief answer. 73.32. In the year 2007, what is the difference between the Oil Rent (as % of GDP) of Small states and Oil Rent (as % of GDP) of Belarus?
Give a very brief answer. 12.12. In the year 2007, what is the difference between the Oil Rent (as % of GDP) in Small states and Oil Rent (as % of GDP) in Congo (Republic)?
Give a very brief answer. -47.03. In the year 2007, what is the difference between the Oil Rent (as % of GDP) in Small states and Oil Rent (as % of GDP) in Slovak Republic?
Give a very brief answer. 13.83. In the year 2007, what is the difference between the Oil Rent (as % of GDP) in Belarus and Oil Rent (as % of GDP) in Congo (Republic)?
Give a very brief answer. -59.15. In the year 2007, what is the difference between the Oil Rent (as % of GDP) of Belarus and Oil Rent (as % of GDP) of Slovak Republic?
Provide a short and direct response. 1.71. In the year 2007, what is the difference between the Oil Rent (as % of GDP) of Congo (Republic) and Oil Rent (as % of GDP) of Slovak Republic?
Ensure brevity in your answer.  60.86. What is the ratio of the Oil Rent (as % of GDP) of Small states in 2001 to that in 2002?
Your answer should be compact. 0.98. What is the ratio of the Oil Rent (as % of GDP) of Belarus in 2001 to that in 2002?
Your answer should be compact. 1.16. What is the ratio of the Oil Rent (as % of GDP) of Congo (Republic) in 2001 to that in 2002?
Offer a terse response. 1.1. What is the ratio of the Oil Rent (as % of GDP) of Slovak Republic in 2001 to that in 2002?
Ensure brevity in your answer.  1.17. What is the ratio of the Oil Rent (as % of GDP) in Small states in 2001 to that in 2003?
Provide a short and direct response. 0.89. What is the ratio of the Oil Rent (as % of GDP) of Belarus in 2001 to that in 2003?
Keep it short and to the point. 1.2. What is the ratio of the Oil Rent (as % of GDP) of Congo (Republic) in 2001 to that in 2003?
Make the answer very short. 1.17. What is the ratio of the Oil Rent (as % of GDP) of Slovak Republic in 2001 to that in 2003?
Provide a succinct answer. 1.36. What is the ratio of the Oil Rent (as % of GDP) in Small states in 2001 to that in 2004?
Ensure brevity in your answer.  0.76. What is the ratio of the Oil Rent (as % of GDP) of Belarus in 2001 to that in 2004?
Give a very brief answer. 1.14. What is the ratio of the Oil Rent (as % of GDP) of Congo (Republic) in 2001 to that in 2004?
Your answer should be compact. 1.09. What is the ratio of the Oil Rent (as % of GDP) in Slovak Republic in 2001 to that in 2004?
Offer a terse response. 1.35. What is the ratio of the Oil Rent (as % of GDP) of Small states in 2001 to that in 2005?
Ensure brevity in your answer.  0.57. What is the ratio of the Oil Rent (as % of GDP) of Belarus in 2001 to that in 2005?
Give a very brief answer. 1.03. What is the ratio of the Oil Rent (as % of GDP) of Congo (Republic) in 2001 to that in 2005?
Keep it short and to the point. 0.9. What is the ratio of the Oil Rent (as % of GDP) in Slovak Republic in 2001 to that in 2005?
Your response must be concise. 1.23. What is the ratio of the Oil Rent (as % of GDP) in Small states in 2001 to that in 2006?
Make the answer very short. 0.53. What is the ratio of the Oil Rent (as % of GDP) of Belarus in 2001 to that in 2006?
Your response must be concise. 1.04. What is the ratio of the Oil Rent (as % of GDP) in Congo (Republic) in 2001 to that in 2006?
Keep it short and to the point. 0.83. What is the ratio of the Oil Rent (as % of GDP) of Slovak Republic in 2001 to that in 2006?
Provide a short and direct response. 1.26. What is the ratio of the Oil Rent (as % of GDP) of Small states in 2001 to that in 2007?
Give a very brief answer. 0.34. What is the ratio of the Oil Rent (as % of GDP) of Belarus in 2001 to that in 2007?
Ensure brevity in your answer.  1.17. What is the ratio of the Oil Rent (as % of GDP) in Congo (Republic) in 2001 to that in 2007?
Ensure brevity in your answer.  1. What is the ratio of the Oil Rent (as % of GDP) of Slovak Republic in 2001 to that in 2007?
Make the answer very short. 1.78. What is the ratio of the Oil Rent (as % of GDP) in Small states in 2002 to that in 2003?
Offer a very short reply. 0.91. What is the ratio of the Oil Rent (as % of GDP) of Belarus in 2002 to that in 2003?
Ensure brevity in your answer.  1.03. What is the ratio of the Oil Rent (as % of GDP) in Congo (Republic) in 2002 to that in 2003?
Make the answer very short. 1.06. What is the ratio of the Oil Rent (as % of GDP) of Slovak Republic in 2002 to that in 2003?
Offer a terse response. 1.16. What is the ratio of the Oil Rent (as % of GDP) in Small states in 2002 to that in 2004?
Give a very brief answer. 0.77. What is the ratio of the Oil Rent (as % of GDP) in Belarus in 2002 to that in 2004?
Offer a terse response. 0.98. What is the ratio of the Oil Rent (as % of GDP) of Slovak Republic in 2002 to that in 2004?
Give a very brief answer. 1.15. What is the ratio of the Oil Rent (as % of GDP) in Small states in 2002 to that in 2005?
Keep it short and to the point. 0.58. What is the ratio of the Oil Rent (as % of GDP) of Belarus in 2002 to that in 2005?
Your answer should be very brief. 0.88. What is the ratio of the Oil Rent (as % of GDP) in Congo (Republic) in 2002 to that in 2005?
Your answer should be very brief. 0.82. What is the ratio of the Oil Rent (as % of GDP) of Slovak Republic in 2002 to that in 2005?
Your answer should be very brief. 1.05. What is the ratio of the Oil Rent (as % of GDP) in Small states in 2002 to that in 2006?
Keep it short and to the point. 0.54. What is the ratio of the Oil Rent (as % of GDP) of Belarus in 2002 to that in 2006?
Keep it short and to the point. 0.89. What is the ratio of the Oil Rent (as % of GDP) of Congo (Republic) in 2002 to that in 2006?
Ensure brevity in your answer.  0.76. What is the ratio of the Oil Rent (as % of GDP) of Slovak Republic in 2002 to that in 2006?
Your answer should be very brief. 1.07. What is the ratio of the Oil Rent (as % of GDP) of Small states in 2002 to that in 2007?
Make the answer very short. 0.34. What is the ratio of the Oil Rent (as % of GDP) in Belarus in 2002 to that in 2007?
Your answer should be very brief. 1.01. What is the ratio of the Oil Rent (as % of GDP) of Congo (Republic) in 2002 to that in 2007?
Your answer should be compact. 0.91. What is the ratio of the Oil Rent (as % of GDP) of Slovak Republic in 2002 to that in 2007?
Provide a succinct answer. 1.52. What is the ratio of the Oil Rent (as % of GDP) of Small states in 2003 to that in 2004?
Your answer should be very brief. 0.85. What is the ratio of the Oil Rent (as % of GDP) in Belarus in 2003 to that in 2004?
Make the answer very short. 0.95. What is the ratio of the Oil Rent (as % of GDP) of Congo (Republic) in 2003 to that in 2004?
Your answer should be very brief. 0.94. What is the ratio of the Oil Rent (as % of GDP) in Slovak Republic in 2003 to that in 2004?
Ensure brevity in your answer.  0.99. What is the ratio of the Oil Rent (as % of GDP) in Small states in 2003 to that in 2005?
Provide a succinct answer. 0.64. What is the ratio of the Oil Rent (as % of GDP) in Belarus in 2003 to that in 2005?
Keep it short and to the point. 0.86. What is the ratio of the Oil Rent (as % of GDP) of Congo (Republic) in 2003 to that in 2005?
Offer a terse response. 0.77. What is the ratio of the Oil Rent (as % of GDP) in Slovak Republic in 2003 to that in 2005?
Provide a succinct answer. 0.9. What is the ratio of the Oil Rent (as % of GDP) of Small states in 2003 to that in 2006?
Give a very brief answer. 0.6. What is the ratio of the Oil Rent (as % of GDP) of Belarus in 2003 to that in 2006?
Give a very brief answer. 0.87. What is the ratio of the Oil Rent (as % of GDP) of Congo (Republic) in 2003 to that in 2006?
Offer a terse response. 0.71. What is the ratio of the Oil Rent (as % of GDP) of Slovak Republic in 2003 to that in 2006?
Keep it short and to the point. 0.92. What is the ratio of the Oil Rent (as % of GDP) of Small states in 2003 to that in 2007?
Your answer should be compact. 0.38. What is the ratio of the Oil Rent (as % of GDP) of Belarus in 2003 to that in 2007?
Offer a very short reply. 0.98. What is the ratio of the Oil Rent (as % of GDP) in Congo (Republic) in 2003 to that in 2007?
Offer a terse response. 0.86. What is the ratio of the Oil Rent (as % of GDP) in Slovak Republic in 2003 to that in 2007?
Provide a short and direct response. 1.3. What is the ratio of the Oil Rent (as % of GDP) of Small states in 2004 to that in 2005?
Your answer should be very brief. 0.75. What is the ratio of the Oil Rent (as % of GDP) in Belarus in 2004 to that in 2005?
Provide a short and direct response. 0.9. What is the ratio of the Oil Rent (as % of GDP) in Congo (Republic) in 2004 to that in 2005?
Offer a terse response. 0.82. What is the ratio of the Oil Rent (as % of GDP) in Slovak Republic in 2004 to that in 2005?
Provide a short and direct response. 0.91. What is the ratio of the Oil Rent (as % of GDP) in Small states in 2004 to that in 2006?
Your response must be concise. 0.7. What is the ratio of the Oil Rent (as % of GDP) in Belarus in 2004 to that in 2006?
Your response must be concise. 0.91. What is the ratio of the Oil Rent (as % of GDP) of Congo (Republic) in 2004 to that in 2006?
Ensure brevity in your answer.  0.76. What is the ratio of the Oil Rent (as % of GDP) in Slovak Republic in 2004 to that in 2006?
Offer a very short reply. 0.94. What is the ratio of the Oil Rent (as % of GDP) of Small states in 2004 to that in 2007?
Keep it short and to the point. 0.44. What is the ratio of the Oil Rent (as % of GDP) of Belarus in 2004 to that in 2007?
Your response must be concise. 1.02. What is the ratio of the Oil Rent (as % of GDP) in Congo (Republic) in 2004 to that in 2007?
Offer a terse response. 0.92. What is the ratio of the Oil Rent (as % of GDP) in Slovak Republic in 2004 to that in 2007?
Your response must be concise. 1.32. What is the ratio of the Oil Rent (as % of GDP) in Small states in 2005 to that in 2006?
Make the answer very short. 0.93. What is the ratio of the Oil Rent (as % of GDP) of Belarus in 2005 to that in 2006?
Give a very brief answer. 1.01. What is the ratio of the Oil Rent (as % of GDP) in Congo (Republic) in 2005 to that in 2006?
Offer a very short reply. 0.93. What is the ratio of the Oil Rent (as % of GDP) in Slovak Republic in 2005 to that in 2006?
Give a very brief answer. 1.03. What is the ratio of the Oil Rent (as % of GDP) in Small states in 2005 to that in 2007?
Offer a terse response. 0.59. What is the ratio of the Oil Rent (as % of GDP) in Belarus in 2005 to that in 2007?
Your answer should be compact. 1.14. What is the ratio of the Oil Rent (as % of GDP) in Congo (Republic) in 2005 to that in 2007?
Your response must be concise. 1.12. What is the ratio of the Oil Rent (as % of GDP) of Slovak Republic in 2005 to that in 2007?
Provide a succinct answer. 1.45. What is the ratio of the Oil Rent (as % of GDP) in Small states in 2006 to that in 2007?
Make the answer very short. 0.63. What is the ratio of the Oil Rent (as % of GDP) in Belarus in 2006 to that in 2007?
Provide a short and direct response. 1.13. What is the ratio of the Oil Rent (as % of GDP) of Congo (Republic) in 2006 to that in 2007?
Ensure brevity in your answer.  1.2. What is the ratio of the Oil Rent (as % of GDP) of Slovak Republic in 2006 to that in 2007?
Keep it short and to the point. 1.41. What is the difference between the highest and the second highest Oil Rent (as % of GDP) in Small states?
Provide a short and direct response. 5.14. What is the difference between the highest and the second highest Oil Rent (as % of GDP) of Belarus?
Provide a short and direct response. 0.05. What is the difference between the highest and the second highest Oil Rent (as % of GDP) in Congo (Republic)?
Ensure brevity in your answer.  5.41. What is the difference between the highest and the second highest Oil Rent (as % of GDP) in Slovak Republic?
Ensure brevity in your answer.  0. What is the difference between the highest and the lowest Oil Rent (as % of GDP) in Small states?
Ensure brevity in your answer.  9.2. What is the difference between the highest and the lowest Oil Rent (as % of GDP) of Belarus?
Make the answer very short. 0.34. What is the difference between the highest and the lowest Oil Rent (as % of GDP) of Congo (Republic)?
Your answer should be compact. 20.91. What is the difference between the highest and the lowest Oil Rent (as % of GDP) of Slovak Republic?
Your answer should be very brief. 0.01. 